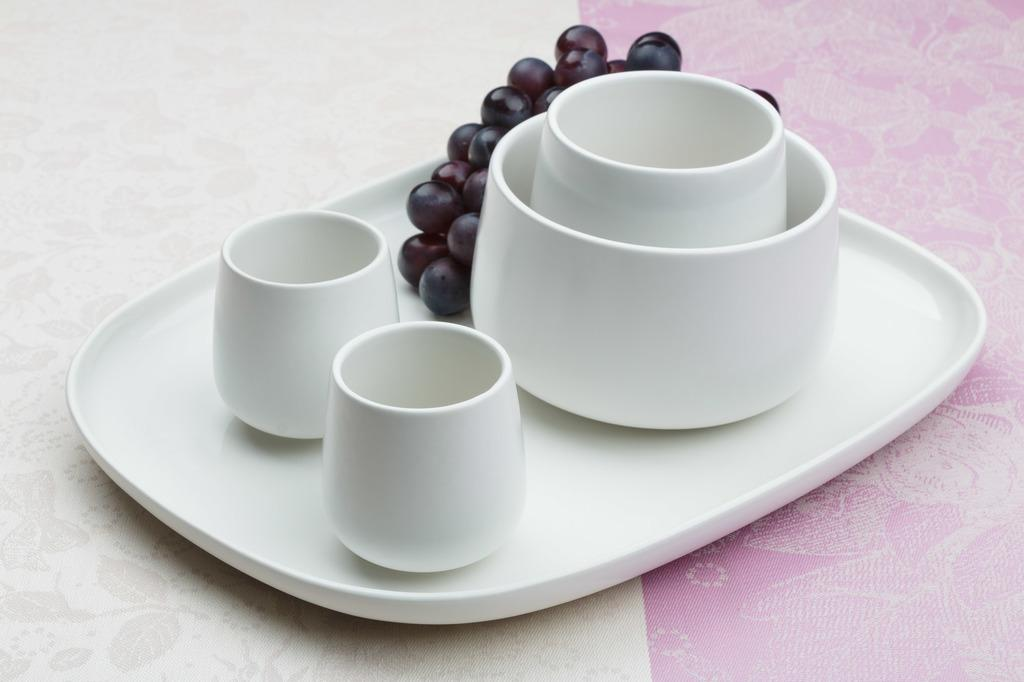What is the color of the tray in the image? The tray is white colored in the image. What items are contained within the tray? The tray contains cups, a bowl, and grapes. On what type of surface is the tray placed? The tray is placed on a surface that resembles a table. What type of ship can be seen sailing in the background of the image? There is no ship visible in the background of the image; it only features a white colored tray with cups, a bowl, and grapes placed on a surface resembling a table. 